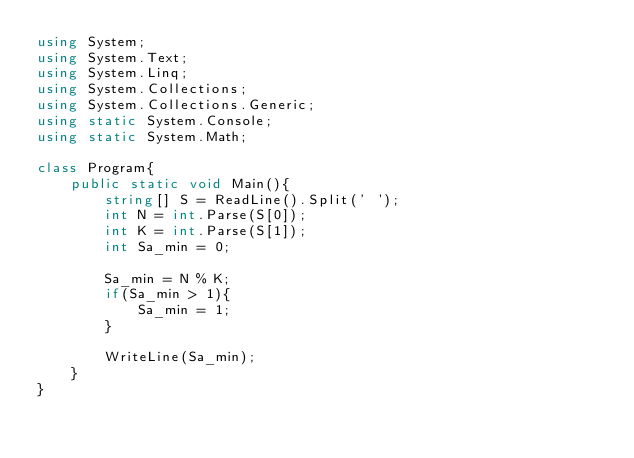<code> <loc_0><loc_0><loc_500><loc_500><_C#_>using System;
using System.Text;
using System.Linq;
using System.Collections;
using System.Collections.Generic;
using static System.Console;
using static System.Math;

class Program{
    public static void Main(){
        string[] S = ReadLine().Split(' ');
        int N = int.Parse(S[0]);
        int K = int.Parse(S[1]);
        int Sa_min = 0;

        Sa_min = N % K;
        if(Sa_min > 1){
            Sa_min = 1;
        }

        WriteLine(Sa_min);
    } 
}</code> 